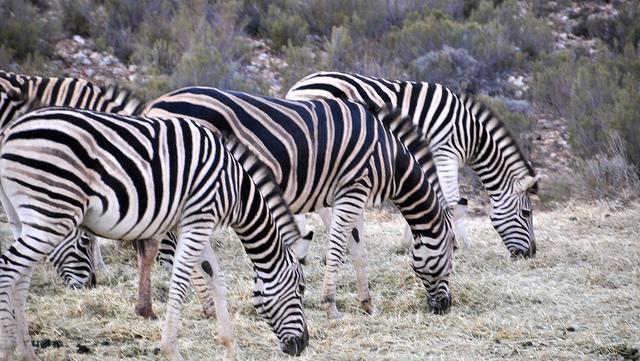How many animals are in this picture?
Give a very brief answer. 4. How many zebras can be seen?
Give a very brief answer. 4. 